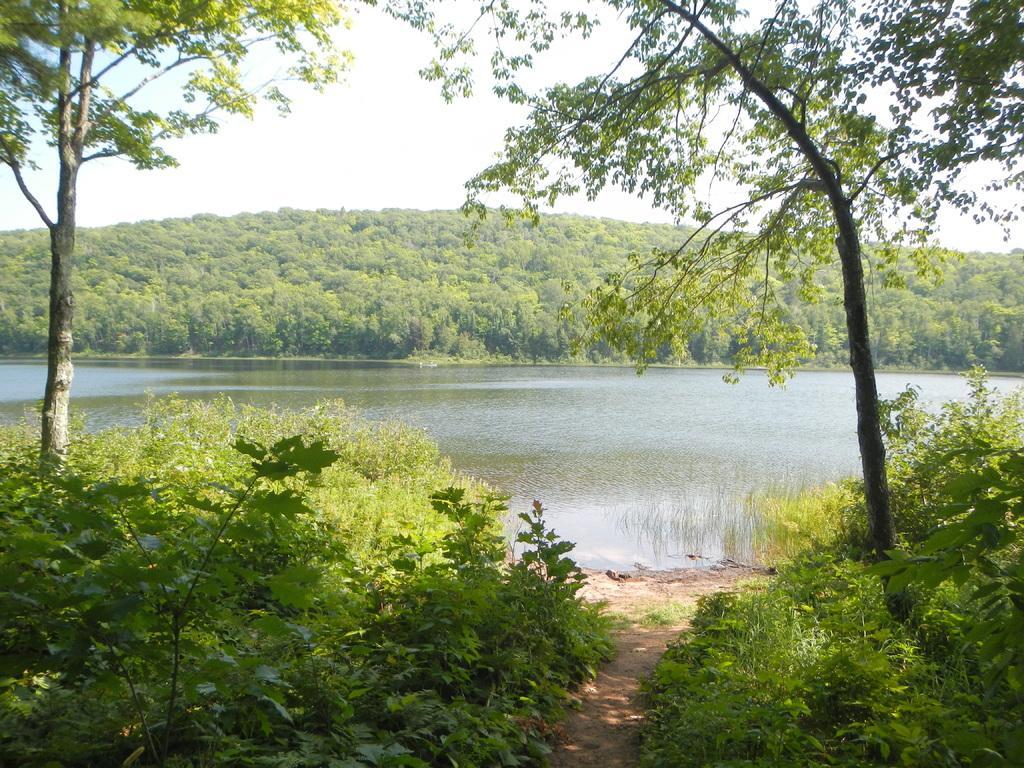Could you give a brief overview of what you see in this image? In this image we can see a group of plants, grass, a water body, a group of trees and the sky which looks cloudy. 